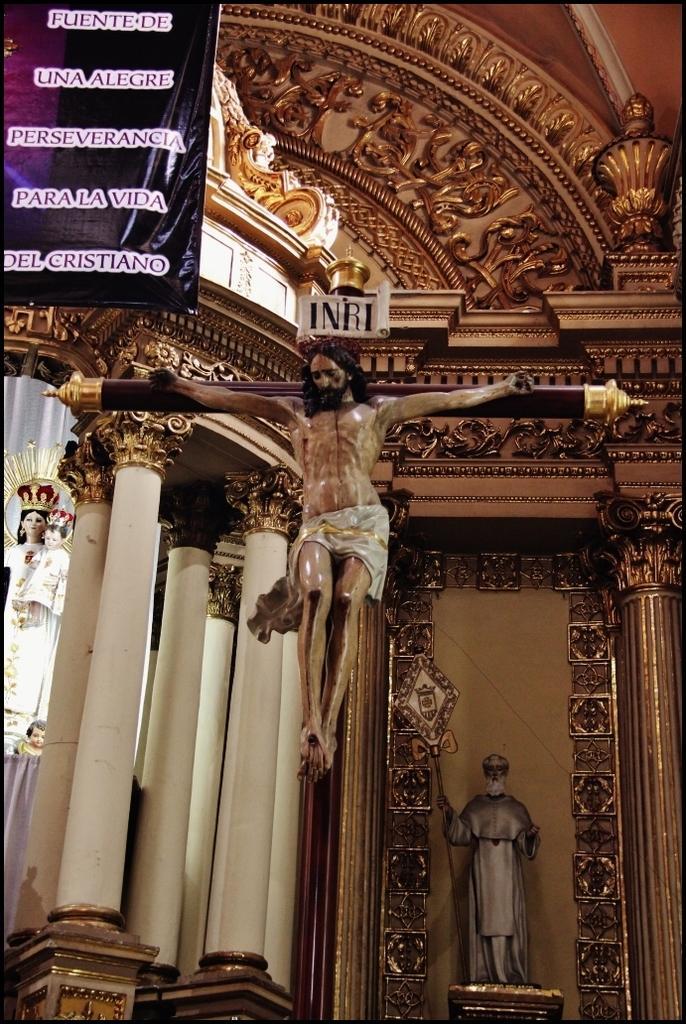Can you describe this image briefly? In the picture I can see the pillars of the cathedral construction. I can see the banner on the top left side. I can see the statues of the goddess. 